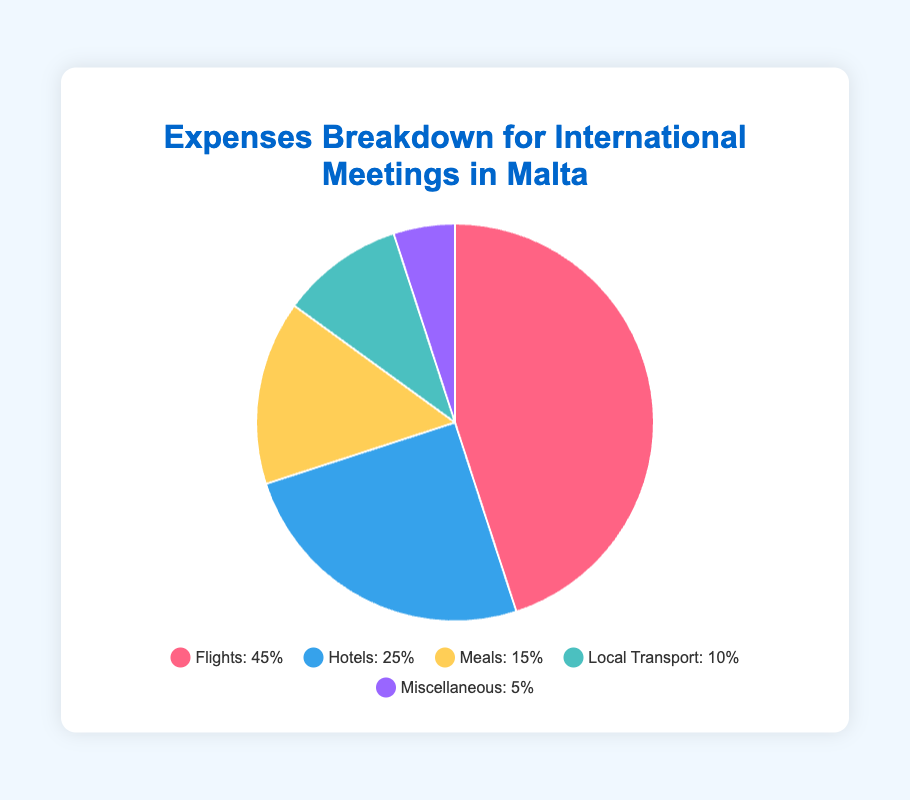What are the two largest expense categories? The largest slices in the pie chart represent the largest expense categories. We see that Flights (45%) and Hotels (25%) are the two largest expenses.
Answer: Flights and Hotels What percentage of the total expenses is spent on Local Transport and Miscellaneous combined? Add the percentages for Local Transport (10%) and Miscellaneous (5%). The total is 10% + 5% = 15%.
Answer: 15% Which category has the smallest percentage of the expenses? The smallest slice in the pie chart corresponds to Miscellaneous, which has the smallest percentage, 5%.
Answer: Miscellaneous How does the percentage spent on Hotels compare to the percentage spent on Meals? Compare the percentages for Hotels (25%) and Meals (15%). Hotels (25%) > Meals (15%) by 10%.
Answer: Hotels are 10% more What is the sum of the percentages for Meals, Local Transport, and Miscellaneous? Sum the percentages for Meals (15%), Local Transport (10%), and Miscellaneous (5%). The total is 15% + 10% + 5% = 30%.
Answer: 30% Which category has a higher percentage, Flights or Hotels and Meals combined? Compare Flights (45%) with the combined total of Hotels and Meals. Add Hotels (25%) and Meals (15%) to get 25% + 15% = 40%. Flights (45%) > Hotels and Meals combined (40%).
Answer: Flights What's the difference in percentage between the highest and lowest expense categories? The highest expense category is Flights (45%) and the lowest is Miscellaneous (5%). The difference is 45% - 5% = 40%.
Answer: 40% What colors represent Hotels and Local Transport in the pie chart? Observing the legend, we see that Hotels are represented by blue, and Local Transport by green.
Answer: Blue and Green How much more is spent on Flights compared to Local Transport? Subtract the percentage for Local Transport (10%) from Flights (45%). The difference is 45% - 10% = 35%.
Answer: 35% Are Hotels and Local Transport expenses together greater than the combined expenses of Meals and Miscellaneous? Add the percentages for Hotels (25%) and Local Transport (10%) to get 35%. Add the percentages for Meals (15%) and Miscellaneous (5%) to get 20%. Compare 35% > 20%.
Answer: Yes 